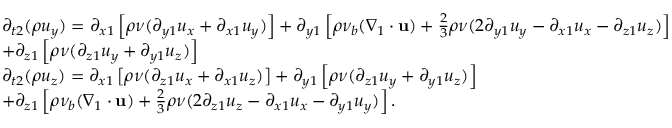<formula> <loc_0><loc_0><loc_500><loc_500>\begin{array} { l } { { \partial _ { t 2 } } ( \rho { u _ { y } } ) = { \partial _ { x 1 } } \left [ { \rho \nu ( { \partial _ { y 1 } } { u _ { x } } + { \partial _ { x 1 } } { u _ { y } } ) } \right ] + { \partial _ { y 1 } } \left [ { \rho { \nu _ { b } } ( { \nabla _ { 1 } } \cdot { u } ) + \frac { 2 } { 3 } \rho \nu ( 2 { \partial _ { y 1 } } { u _ { y } } - { \partial _ { x 1 } } { u _ { x } } - { \partial _ { z 1 } } { u _ { z } } ) } \right ] } \\ { + { \partial _ { z 1 } } \left [ { \rho \nu ( { \partial _ { z 1 } } { u _ { y } } + { \partial _ { y 1 } } { u _ { z } } ) } \right ] } \\ { { \partial _ { t 2 } } ( \rho { u _ { z } } ) = { \partial _ { x 1 } } \left [ { \rho \nu ( { \partial _ { z 1 } } { u _ { x } } + { \partial _ { x 1 } } { u _ { z } } ) } \right ] + { \partial _ { y 1 } } \left [ { \rho \nu ( { \partial _ { z 1 } } { u _ { y } } + { \partial _ { y 1 } } { u _ { z } } ) } \right ] } \\ { + { \partial _ { z 1 } } \left [ { \rho { \nu _ { b } } ( { \nabla _ { 1 } } \cdot { u } ) + \frac { 2 } { 3 } \rho \nu ( 2 { \partial _ { z 1 } } { u _ { z } } - { \partial _ { x 1 } } { u _ { x } } - { \partial _ { y 1 } } { u _ { y } } ) } \right ] . } \end{array}</formula> 